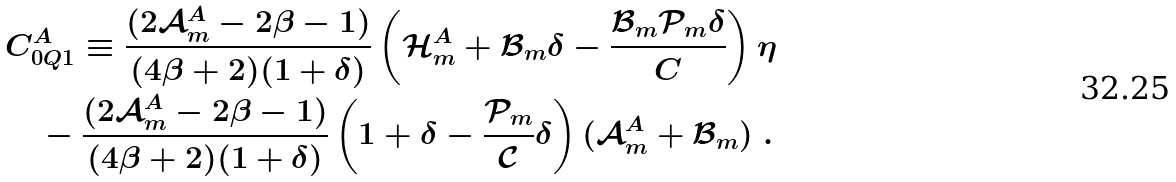<formula> <loc_0><loc_0><loc_500><loc_500>& C ^ { A } _ { 0 Q 1 } \equiv \frac { ( 2 \mathcal { A } ^ { A } _ { m } - 2 \beta - 1 ) } { ( 4 \beta + 2 ) ( 1 + \delta ) } \left ( \mathcal { H } ^ { A } _ { m } + \mathcal { B } _ { m } \delta - \frac { \mathcal { B } _ { m } \mathcal { P } _ { m } \delta } { C } \right ) \eta \\ & \quad - \frac { ( 2 \mathcal { A } ^ { A } _ { m } - 2 \beta - 1 ) } { ( 4 \beta + 2 ) ( 1 + \delta ) } \left ( 1 + \delta - \frac { \mathcal { P } _ { m } } { \mathcal { C } } \delta \right ) ( \mathcal { A } ^ { A } _ { m } + \mathcal { B } _ { m } ) \ .</formula> 